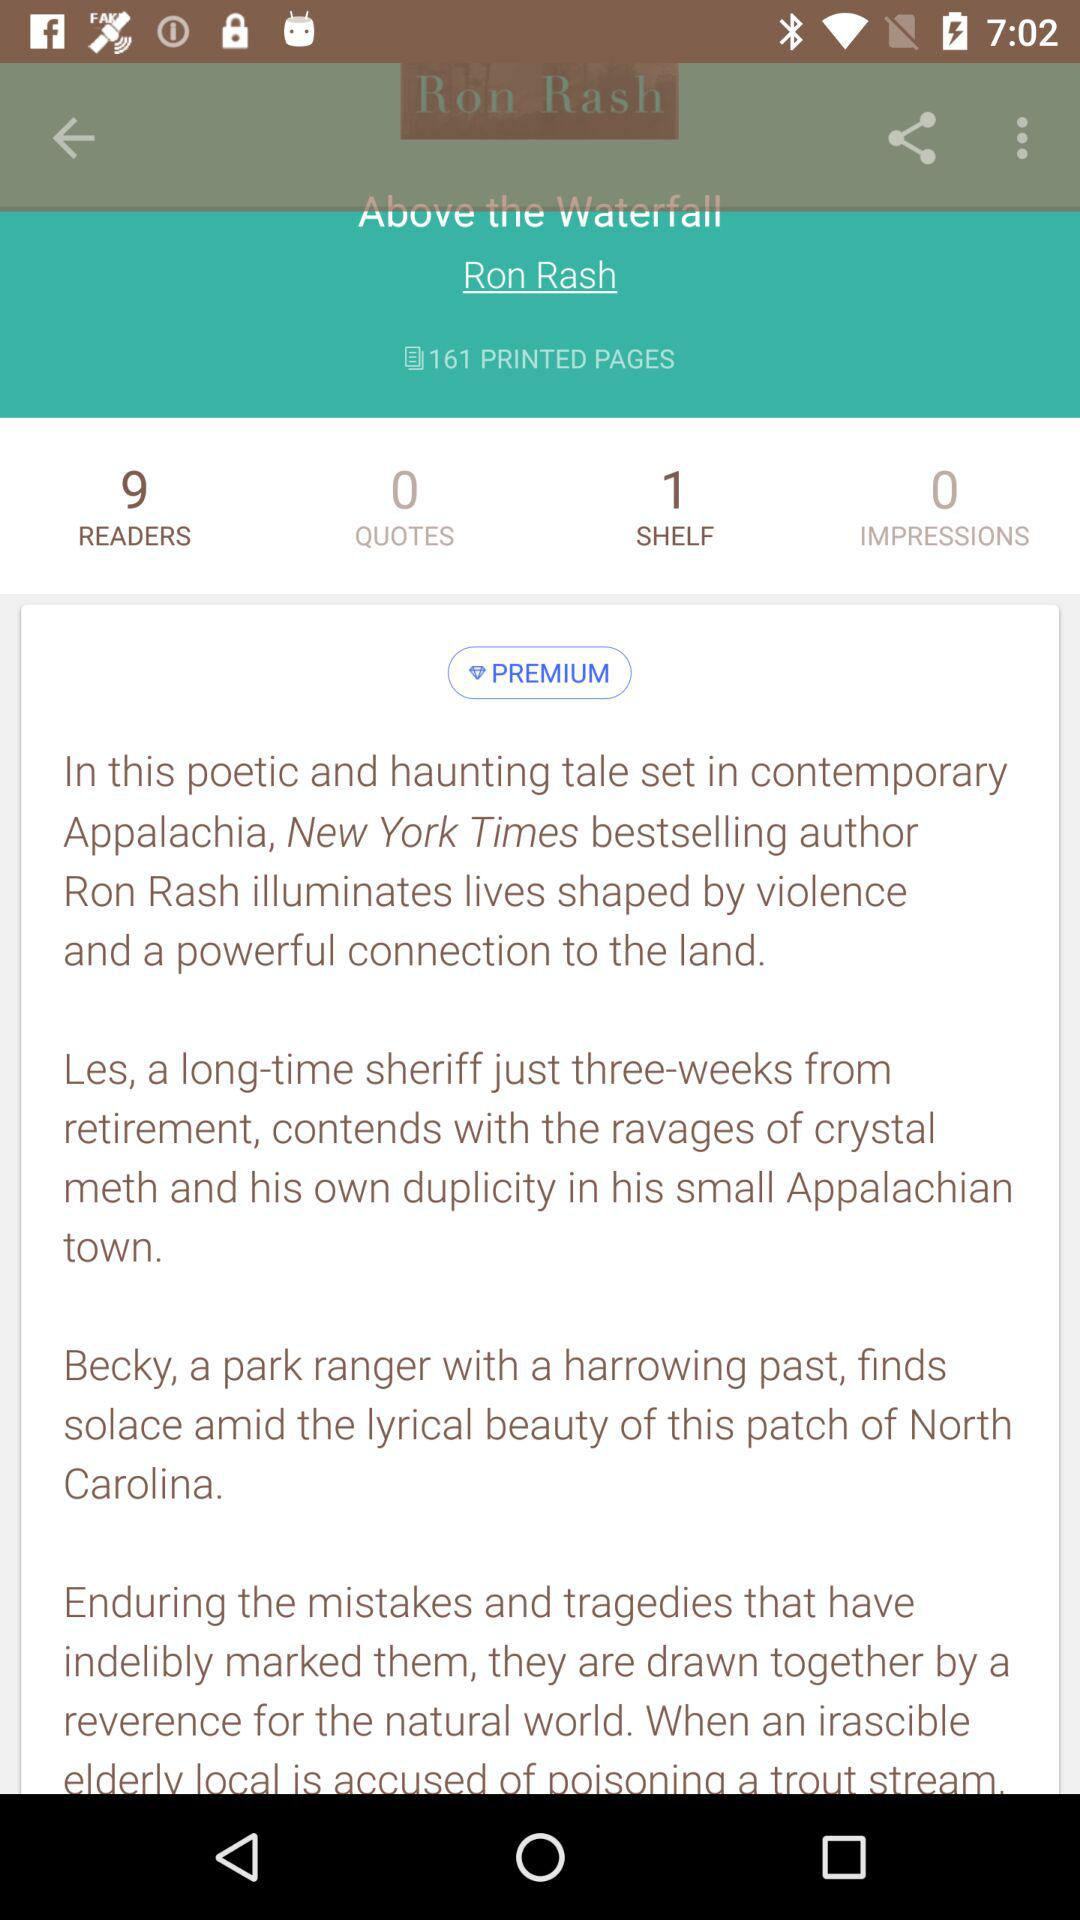How many readers are there? There are 9 readers. 